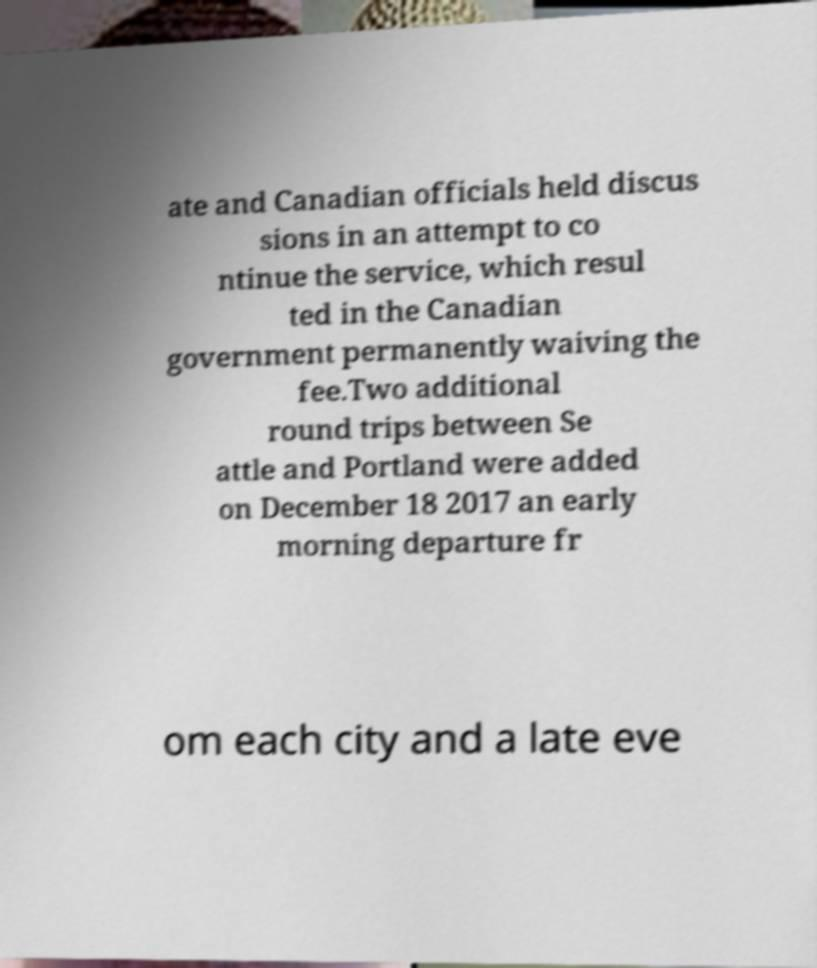Please identify and transcribe the text found in this image. ate and Canadian officials held discus sions in an attempt to co ntinue the service, which resul ted in the Canadian government permanently waiving the fee.Two additional round trips between Se attle and Portland were added on December 18 2017 an early morning departure fr om each city and a late eve 